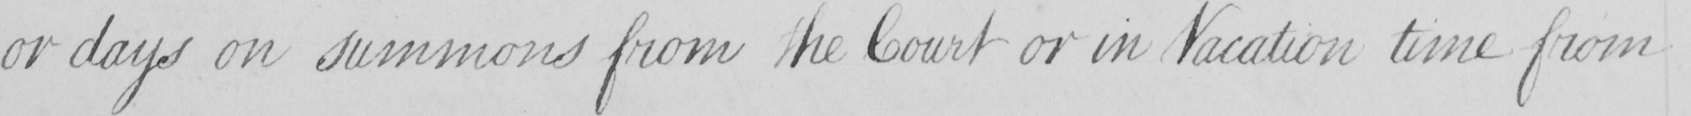Please provide the text content of this handwritten line. or days on summons from the Court or in Vacation time from 